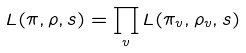Convert formula to latex. <formula><loc_0><loc_0><loc_500><loc_500>L ( \pi , \rho , s ) = \prod _ { v } L ( \pi _ { v } , \rho _ { v } , s )</formula> 